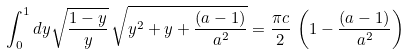Convert formula to latex. <formula><loc_0><loc_0><loc_500><loc_500>\int _ { 0 } ^ { 1 } d y \sqrt { \frac { 1 - y } { y } } \, \sqrt { y ^ { 2 } + y + \frac { ( a - 1 ) } { a ^ { 2 } } } = \frac { \pi c } { 2 } \, \left ( 1 - \frac { ( a - 1 ) } { a ^ { 2 } } \right )</formula> 